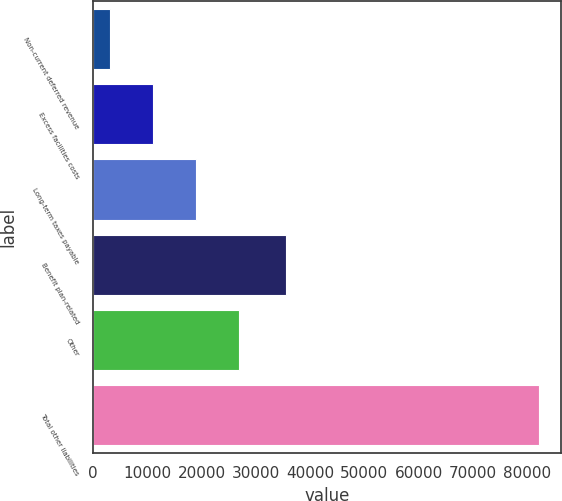Convert chart. <chart><loc_0><loc_0><loc_500><loc_500><bar_chart><fcel>Non-current deferred revenue<fcel>Excess facilities costs<fcel>Long-term taxes payable<fcel>Benefit plan-related<fcel>Other<fcel>Total other liabilities<nl><fcel>3083<fcel>10994.7<fcel>18906.4<fcel>35545<fcel>26818.1<fcel>82200<nl></chart> 